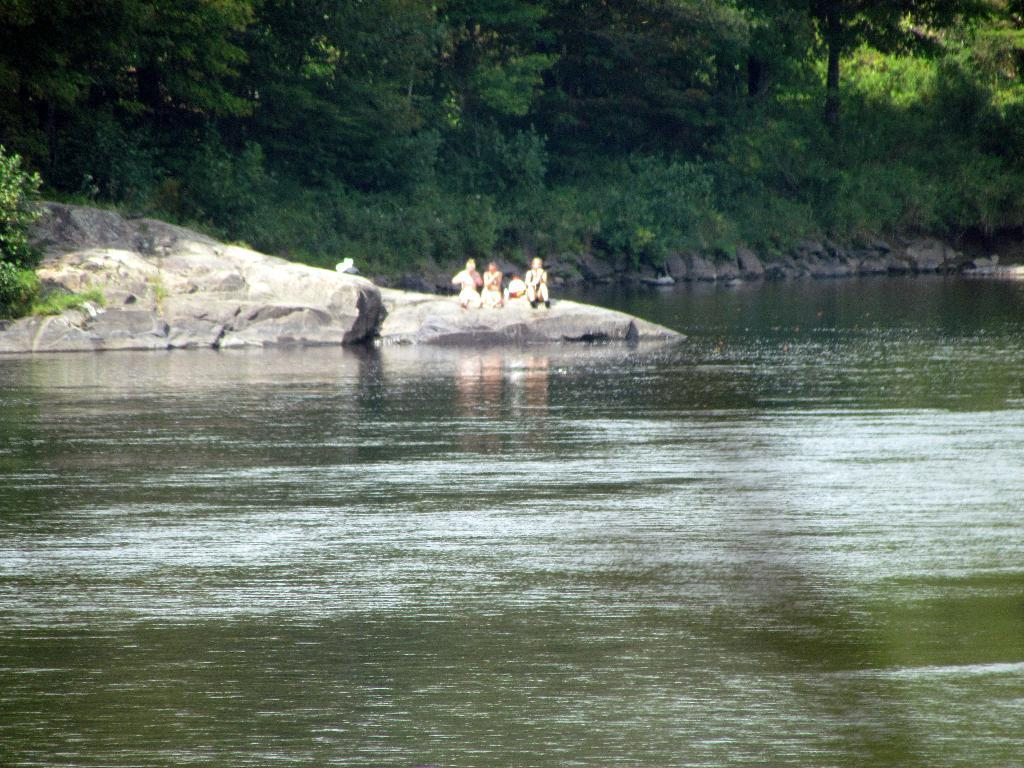What is the primary element in the image? There is water in the image. What are the people in the image doing? There are three people sitting on rocks in the image. Can you describe any objects in the image? There are objects in the image, but their specific nature is not mentioned in the facts. What can be seen in the background of the image? There are trees in the background of the image. What type of chair is visible in the image? There is no chair present in the image. Is there a quill being used by any of the people in the image? There is no mention of a quill or any writing instrument in the image. 